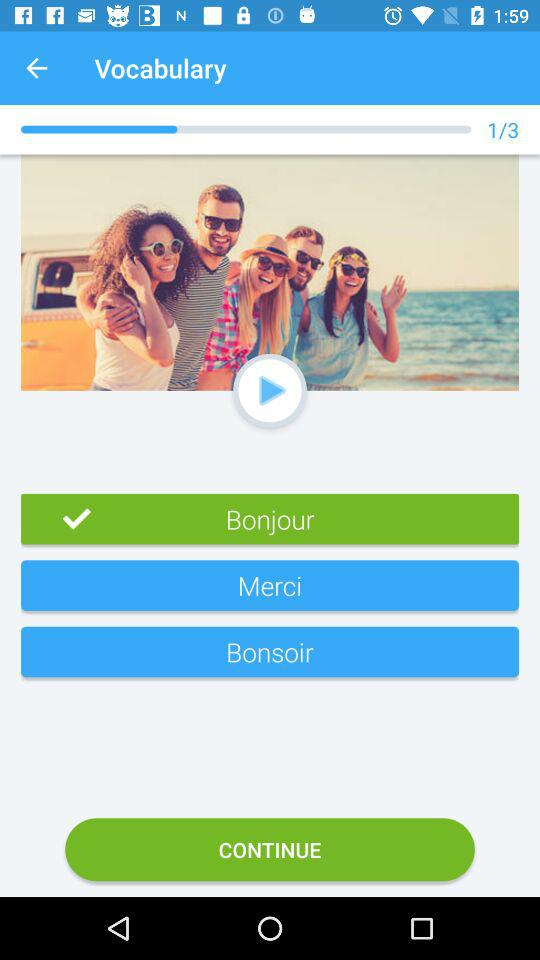Which option is selected in "Vocabulary"? The selected option is "Bonjour". 